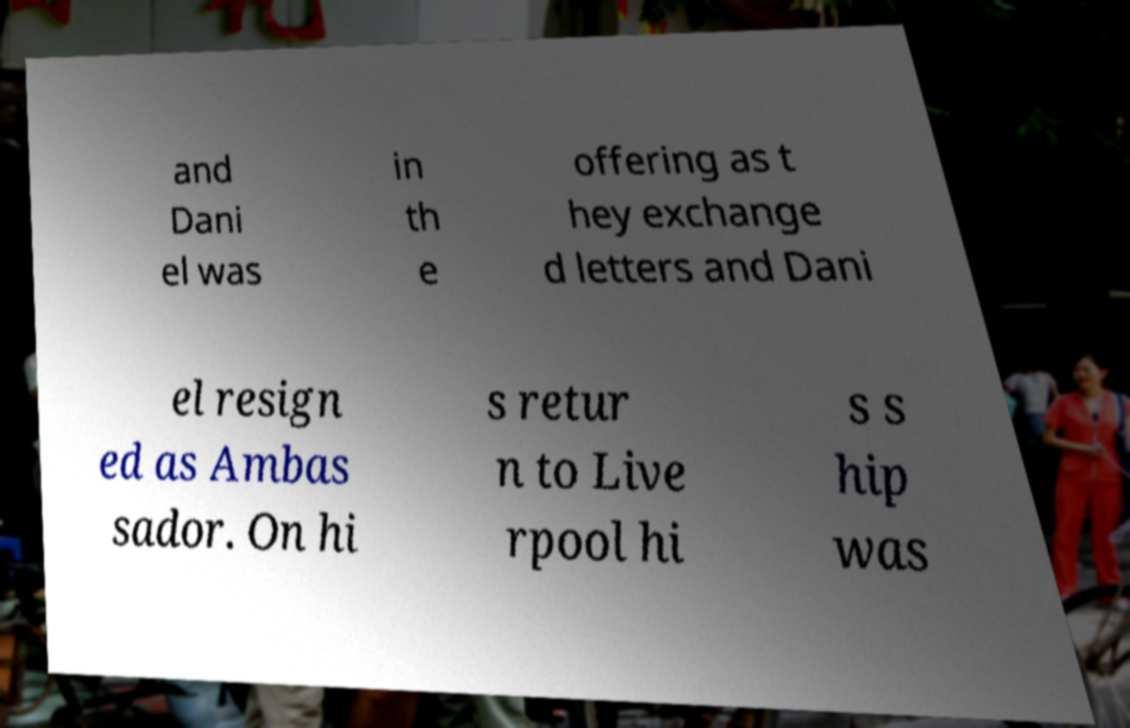For documentation purposes, I need the text within this image transcribed. Could you provide that? and Dani el was in th e offering as t hey exchange d letters and Dani el resign ed as Ambas sador. On hi s retur n to Live rpool hi s s hip was 